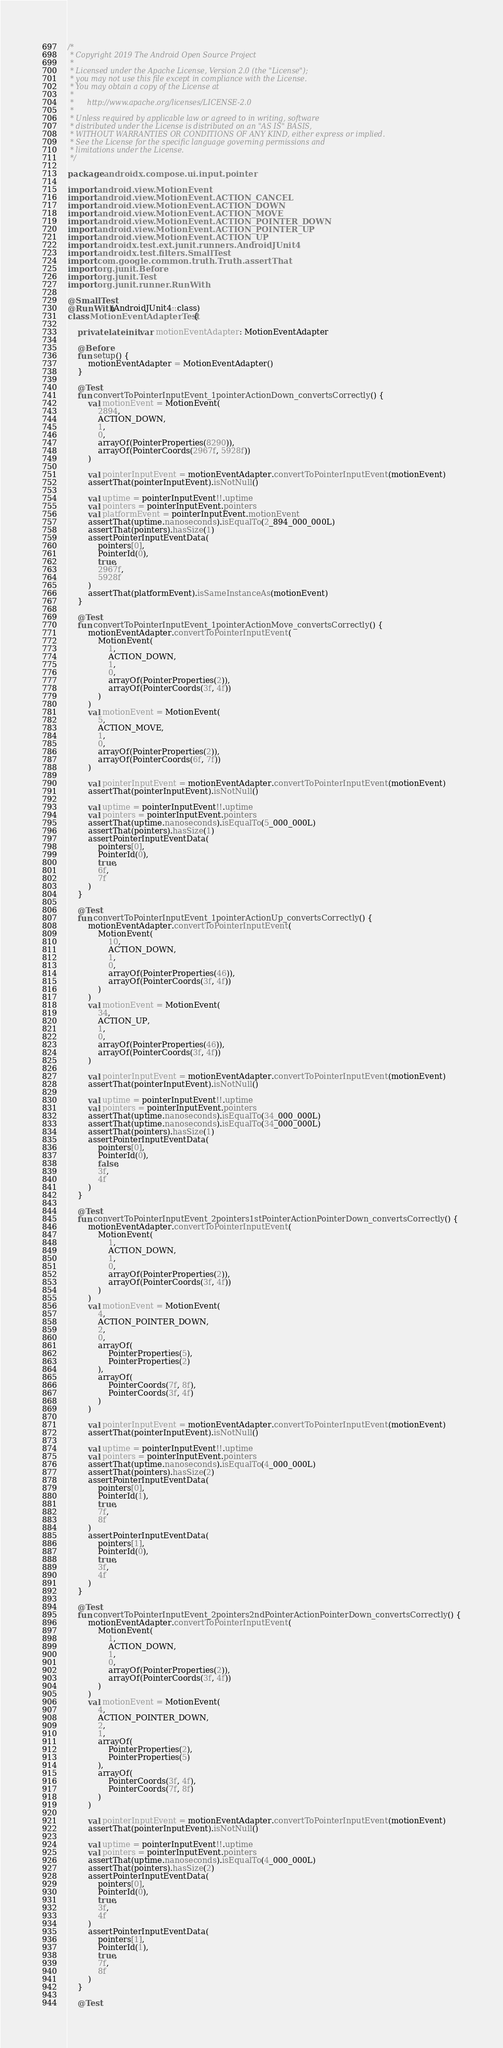<code> <loc_0><loc_0><loc_500><loc_500><_Kotlin_>/*
 * Copyright 2019 The Android Open Source Project
 *
 * Licensed under the Apache License, Version 2.0 (the "License");
 * you may not use this file except in compliance with the License.
 * You may obtain a copy of the License at
 *
 *      http://www.apache.org/licenses/LICENSE-2.0
 *
 * Unless required by applicable law or agreed to in writing, software
 * distributed under the License is distributed on an "AS IS" BASIS,
 * WITHOUT WARRANTIES OR CONDITIONS OF ANY KIND, either express or implied.
 * See the License for the specific language governing permissions and
 * limitations under the License.
 */

package androidx.compose.ui.input.pointer

import android.view.MotionEvent
import android.view.MotionEvent.ACTION_CANCEL
import android.view.MotionEvent.ACTION_DOWN
import android.view.MotionEvent.ACTION_MOVE
import android.view.MotionEvent.ACTION_POINTER_DOWN
import android.view.MotionEvent.ACTION_POINTER_UP
import android.view.MotionEvent.ACTION_UP
import androidx.test.ext.junit.runners.AndroidJUnit4
import androidx.test.filters.SmallTest
import com.google.common.truth.Truth.assertThat
import org.junit.Before
import org.junit.Test
import org.junit.runner.RunWith

@SmallTest
@RunWith(AndroidJUnit4::class)
class MotionEventAdapterTest {

    private lateinit var motionEventAdapter: MotionEventAdapter

    @Before
    fun setup() {
        motionEventAdapter = MotionEventAdapter()
    }

    @Test
    fun convertToPointerInputEvent_1pointerActionDown_convertsCorrectly() {
        val motionEvent = MotionEvent(
            2894,
            ACTION_DOWN,
            1,
            0,
            arrayOf(PointerProperties(8290)),
            arrayOf(PointerCoords(2967f, 5928f))
        )

        val pointerInputEvent = motionEventAdapter.convertToPointerInputEvent(motionEvent)
        assertThat(pointerInputEvent).isNotNull()

        val uptime = pointerInputEvent!!.uptime
        val pointers = pointerInputEvent.pointers
        val platformEvent = pointerInputEvent.motionEvent
        assertThat(uptime.nanoseconds).isEqualTo(2_894_000_000L)
        assertThat(pointers).hasSize(1)
        assertPointerInputEventData(
            pointers[0],
            PointerId(0),
            true,
            2967f,
            5928f
        )
        assertThat(platformEvent).isSameInstanceAs(motionEvent)
    }

    @Test
    fun convertToPointerInputEvent_1pointerActionMove_convertsCorrectly() {
        motionEventAdapter.convertToPointerInputEvent(
            MotionEvent(
                1,
                ACTION_DOWN,
                1,
                0,
                arrayOf(PointerProperties(2)),
                arrayOf(PointerCoords(3f, 4f))
            )
        )
        val motionEvent = MotionEvent(
            5,
            ACTION_MOVE,
            1,
            0,
            arrayOf(PointerProperties(2)),
            arrayOf(PointerCoords(6f, 7f))
        )

        val pointerInputEvent = motionEventAdapter.convertToPointerInputEvent(motionEvent)
        assertThat(pointerInputEvent).isNotNull()

        val uptime = pointerInputEvent!!.uptime
        val pointers = pointerInputEvent.pointers
        assertThat(uptime.nanoseconds).isEqualTo(5_000_000L)
        assertThat(pointers).hasSize(1)
        assertPointerInputEventData(
            pointers[0],
            PointerId(0),
            true,
            6f,
            7f
        )
    }

    @Test
    fun convertToPointerInputEvent_1pointerActionUp_convertsCorrectly() {
        motionEventAdapter.convertToPointerInputEvent(
            MotionEvent(
                10,
                ACTION_DOWN,
                1,
                0,
                arrayOf(PointerProperties(46)),
                arrayOf(PointerCoords(3f, 4f))
            )
        )
        val motionEvent = MotionEvent(
            34,
            ACTION_UP,
            1,
            0,
            arrayOf(PointerProperties(46)),
            arrayOf(PointerCoords(3f, 4f))
        )

        val pointerInputEvent = motionEventAdapter.convertToPointerInputEvent(motionEvent)
        assertThat(pointerInputEvent).isNotNull()

        val uptime = pointerInputEvent!!.uptime
        val pointers = pointerInputEvent.pointers
        assertThat(uptime.nanoseconds).isEqualTo(34_000_000L)
        assertThat(uptime.nanoseconds).isEqualTo(34_000_000L)
        assertThat(pointers).hasSize(1)
        assertPointerInputEventData(
            pointers[0],
            PointerId(0),
            false,
            3f,
            4f
        )
    }

    @Test
    fun convertToPointerInputEvent_2pointers1stPointerActionPointerDown_convertsCorrectly() {
        motionEventAdapter.convertToPointerInputEvent(
            MotionEvent(
                1,
                ACTION_DOWN,
                1,
                0,
                arrayOf(PointerProperties(2)),
                arrayOf(PointerCoords(3f, 4f))
            )
        )
        val motionEvent = MotionEvent(
            4,
            ACTION_POINTER_DOWN,
            2,
            0,
            arrayOf(
                PointerProperties(5),
                PointerProperties(2)
            ),
            arrayOf(
                PointerCoords(7f, 8f),
                PointerCoords(3f, 4f)
            )
        )

        val pointerInputEvent = motionEventAdapter.convertToPointerInputEvent(motionEvent)
        assertThat(pointerInputEvent).isNotNull()

        val uptime = pointerInputEvent!!.uptime
        val pointers = pointerInputEvent.pointers
        assertThat(uptime.nanoseconds).isEqualTo(4_000_000L)
        assertThat(pointers).hasSize(2)
        assertPointerInputEventData(
            pointers[0],
            PointerId(1),
            true,
            7f,
            8f
        )
        assertPointerInputEventData(
            pointers[1],
            PointerId(0),
            true,
            3f,
            4f
        )
    }

    @Test
    fun convertToPointerInputEvent_2pointers2ndPointerActionPointerDown_convertsCorrectly() {
        motionEventAdapter.convertToPointerInputEvent(
            MotionEvent(
                1,
                ACTION_DOWN,
                1,
                0,
                arrayOf(PointerProperties(2)),
                arrayOf(PointerCoords(3f, 4f))
            )
        )
        val motionEvent = MotionEvent(
            4,
            ACTION_POINTER_DOWN,
            2,
            1,
            arrayOf(
                PointerProperties(2),
                PointerProperties(5)
            ),
            arrayOf(
                PointerCoords(3f, 4f),
                PointerCoords(7f, 8f)
            )
        )

        val pointerInputEvent = motionEventAdapter.convertToPointerInputEvent(motionEvent)
        assertThat(pointerInputEvent).isNotNull()

        val uptime = pointerInputEvent!!.uptime
        val pointers = pointerInputEvent.pointers
        assertThat(uptime.nanoseconds).isEqualTo(4_000_000L)
        assertThat(pointers).hasSize(2)
        assertPointerInputEventData(
            pointers[0],
            PointerId(0),
            true,
            3f,
            4f
        )
        assertPointerInputEventData(
            pointers[1],
            PointerId(1),
            true,
            7f,
            8f
        )
    }

    @Test</code> 